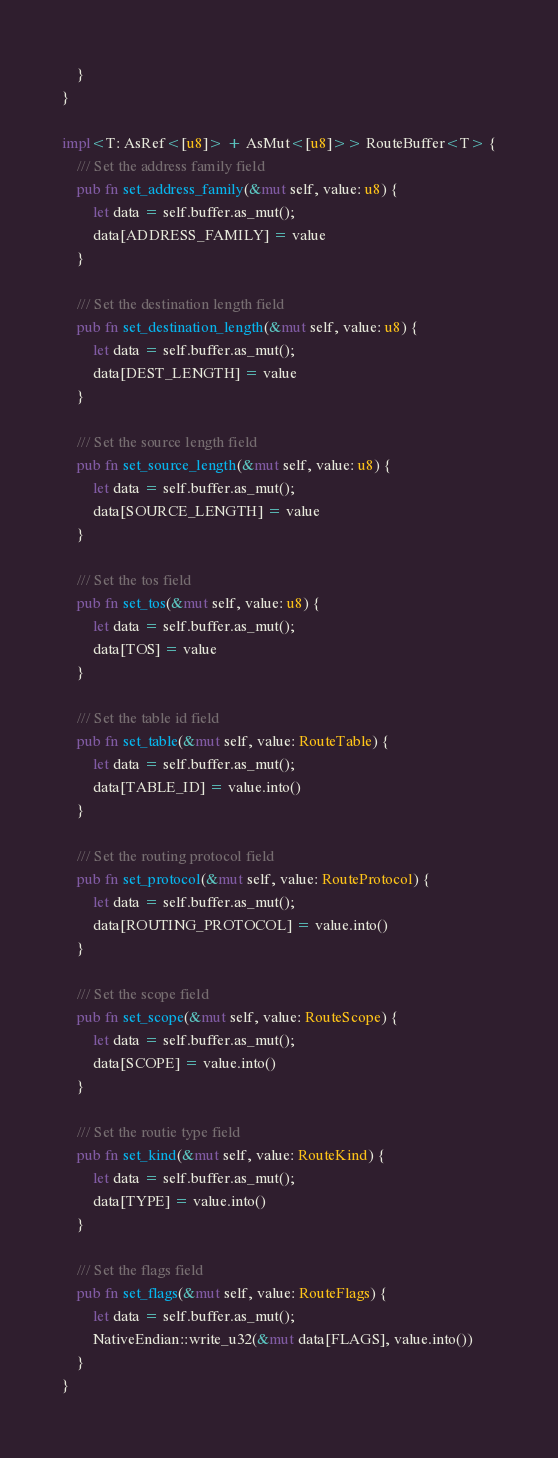Convert code to text. <code><loc_0><loc_0><loc_500><loc_500><_Rust_>    }
}

impl<T: AsRef<[u8]> + AsMut<[u8]>> RouteBuffer<T> {
    /// Set the address family field
    pub fn set_address_family(&mut self, value: u8) {
        let data = self.buffer.as_mut();
        data[ADDRESS_FAMILY] = value
    }

    /// Set the destination length field
    pub fn set_destination_length(&mut self, value: u8) {
        let data = self.buffer.as_mut();
        data[DEST_LENGTH] = value
    }

    /// Set the source length field
    pub fn set_source_length(&mut self, value: u8) {
        let data = self.buffer.as_mut();
        data[SOURCE_LENGTH] = value
    }

    /// Set the tos field
    pub fn set_tos(&mut self, value: u8) {
        let data = self.buffer.as_mut();
        data[TOS] = value
    }

    /// Set the table id field
    pub fn set_table(&mut self, value: RouteTable) {
        let data = self.buffer.as_mut();
        data[TABLE_ID] = value.into()
    }

    /// Set the routing protocol field
    pub fn set_protocol(&mut self, value: RouteProtocol) {
        let data = self.buffer.as_mut();
        data[ROUTING_PROTOCOL] = value.into()
    }

    /// Set the scope field
    pub fn set_scope(&mut self, value: RouteScope) {
        let data = self.buffer.as_mut();
        data[SCOPE] = value.into()
    }

    /// Set the routie type field
    pub fn set_kind(&mut self, value: RouteKind) {
        let data = self.buffer.as_mut();
        data[TYPE] = value.into()
    }

    /// Set the flags field
    pub fn set_flags(&mut self, value: RouteFlags) {
        let data = self.buffer.as_mut();
        NativeEndian::write_u32(&mut data[FLAGS], value.into())
    }
}
</code> 